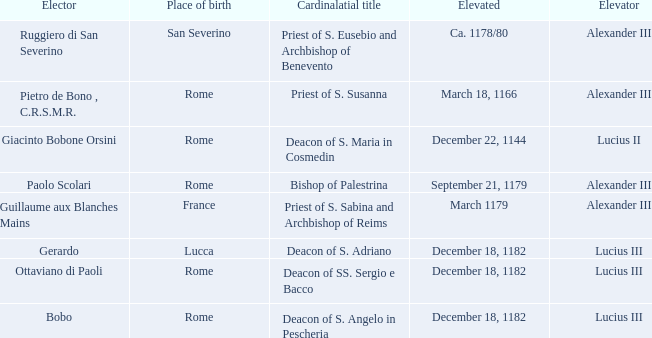What is the Elevator of the Elected Elevated on September 21, 1179? Alexander III. 